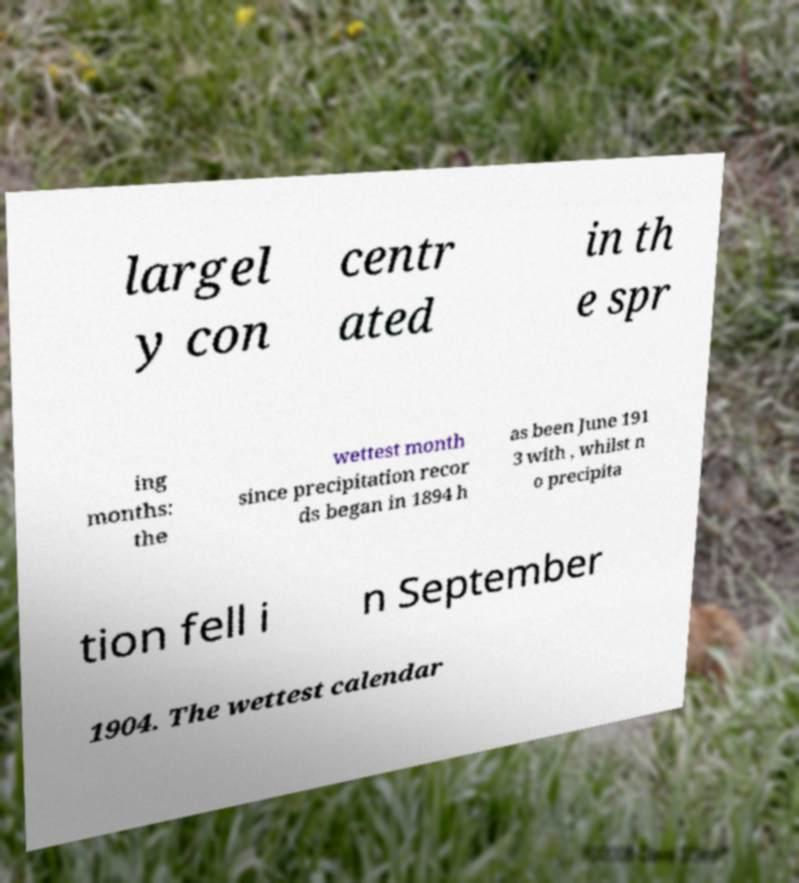Could you assist in decoding the text presented in this image and type it out clearly? largel y con centr ated in th e spr ing months: the wettest month since precipitation recor ds began in 1894 h as been June 191 3 with , whilst n o precipita tion fell i n September 1904. The wettest calendar 